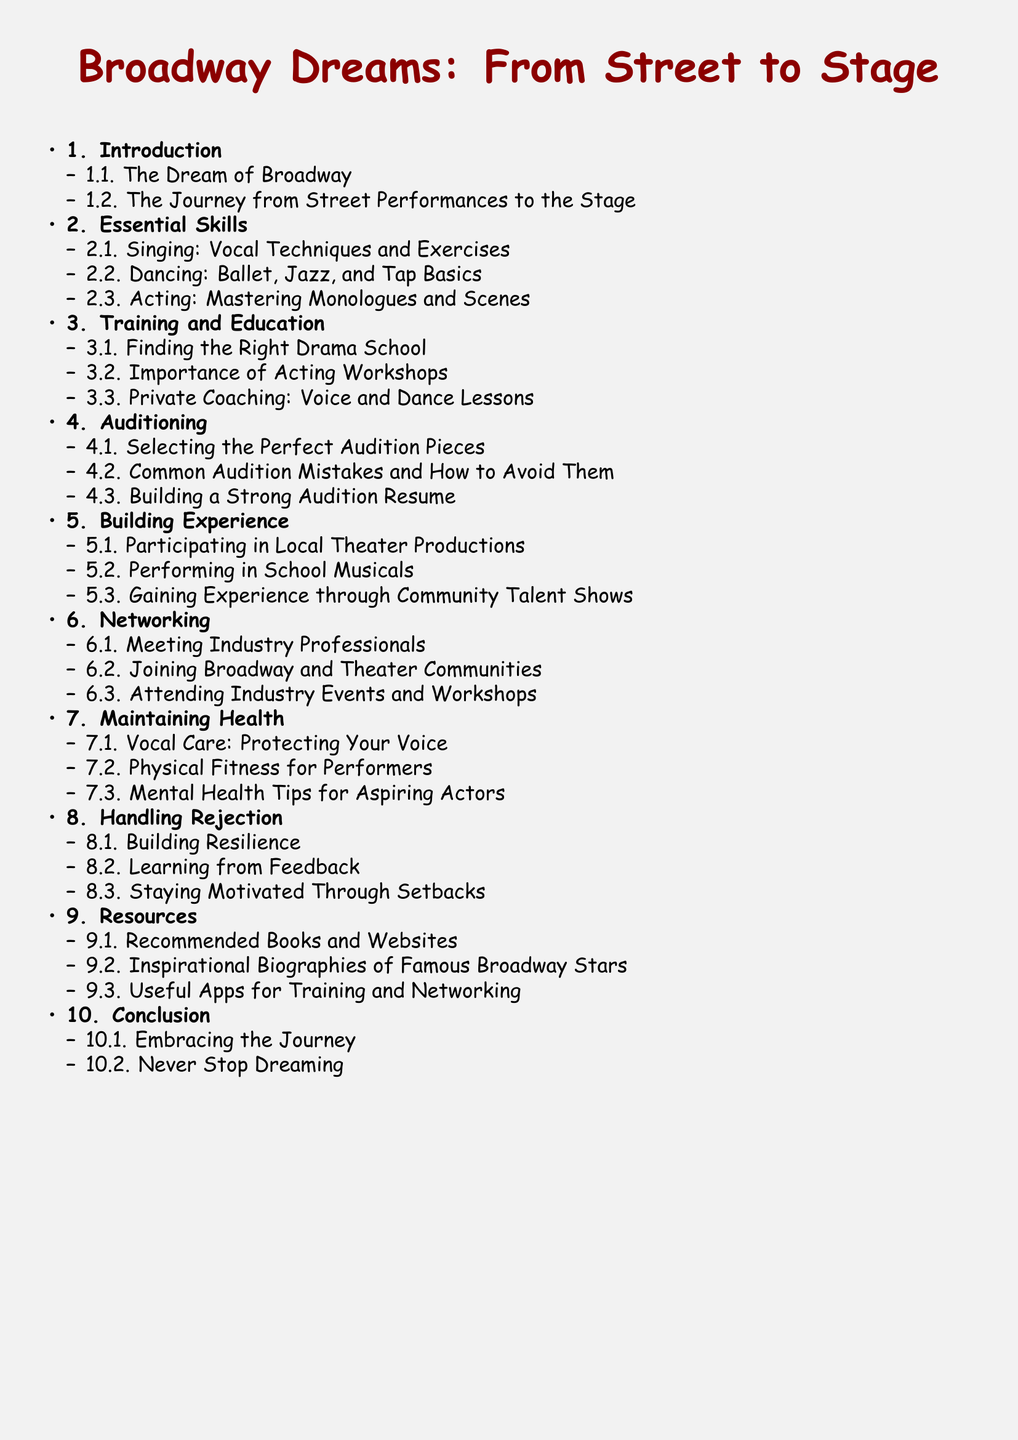What is the first section in the document? The first section listed in the Table of contents is "Introduction."
Answer: Introduction How many subsections are there under "Essential Skills"? The second section, "Essential Skills," has three subsections.
Answer: 3 What is included in "Training and Education"? The third section, "Training and Education," covers three topics.
Answer: Finding the Right Drama School, Importance of Acting Workshops, Private Coaching: Voice and Dance Lessons What is the last topic in the "Building Experience" section? The last item under "Building Experience" is "Gaining Experience through Community Talent Shows."
Answer: Gaining Experience through Community Talent Shows How does the document address mental well-being for performers? The section on maintaining health includes "Mental Health Tips for Aspiring Actors."
Answer: Mental Health Tips for Aspiring Actors What section discusses rejection? The section titled "Handling Rejection" focuses on this topic.
Answer: Handling Rejection What is the purpose of "Networking" in this document? Networking is about creating connections in the theater community and industry.
Answer: Meeting Industry Professionals, Joining Broadway and Theater Communities, Attending Industry Events and Workshops How many sections are there in total? There are ten sections in the document’s Table of contents.
Answer: 10 Which color is specified for the first level of section titles? The first level of section titles is colored "curtainred."
Answer: curtainred 